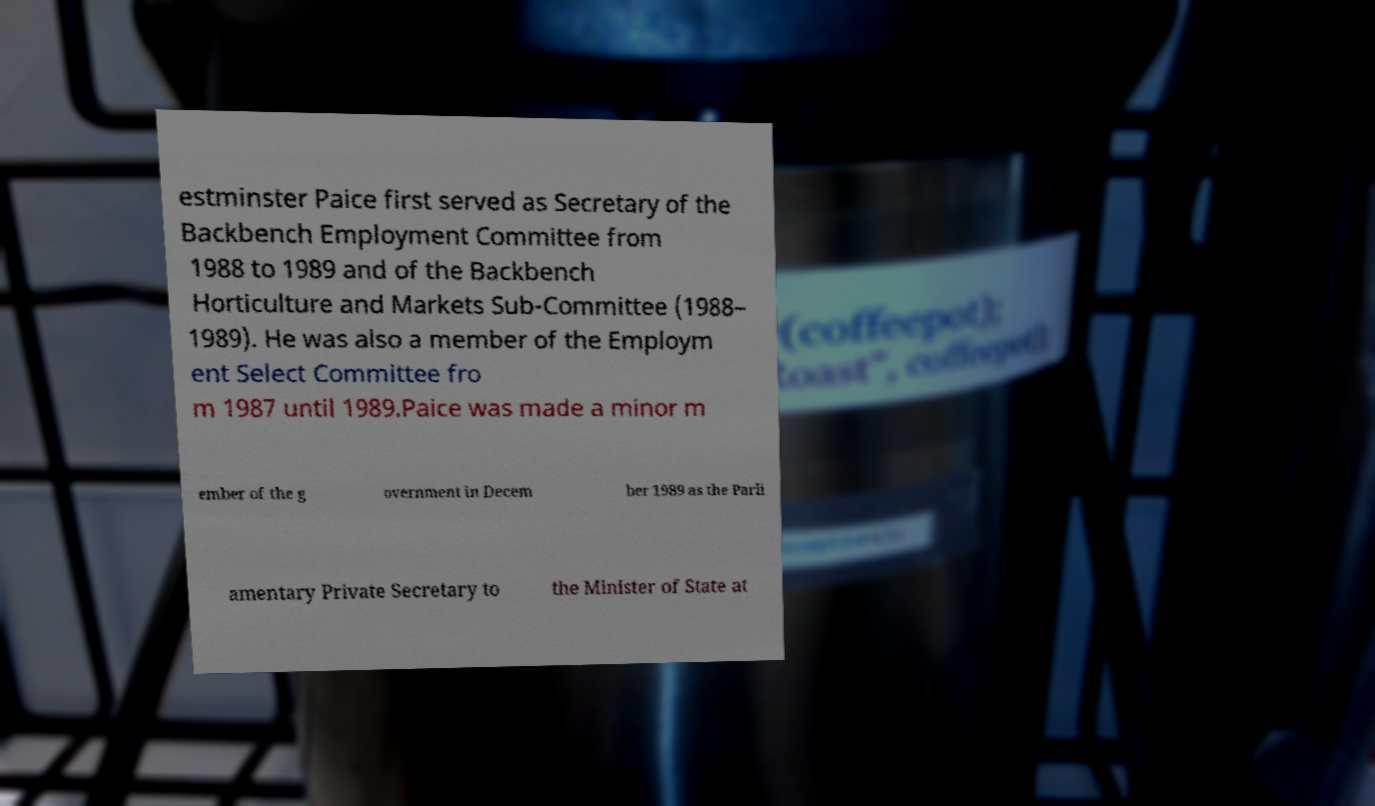Please read and relay the text visible in this image. What does it say? estminster Paice first served as Secretary of the Backbench Employment Committee from 1988 to 1989 and of the Backbench Horticulture and Markets Sub-Committee (1988– 1989). He was also a member of the Employm ent Select Committee fro m 1987 until 1989.Paice was made a minor m ember of the g overnment in Decem ber 1989 as the Parli amentary Private Secretary to the Minister of State at 